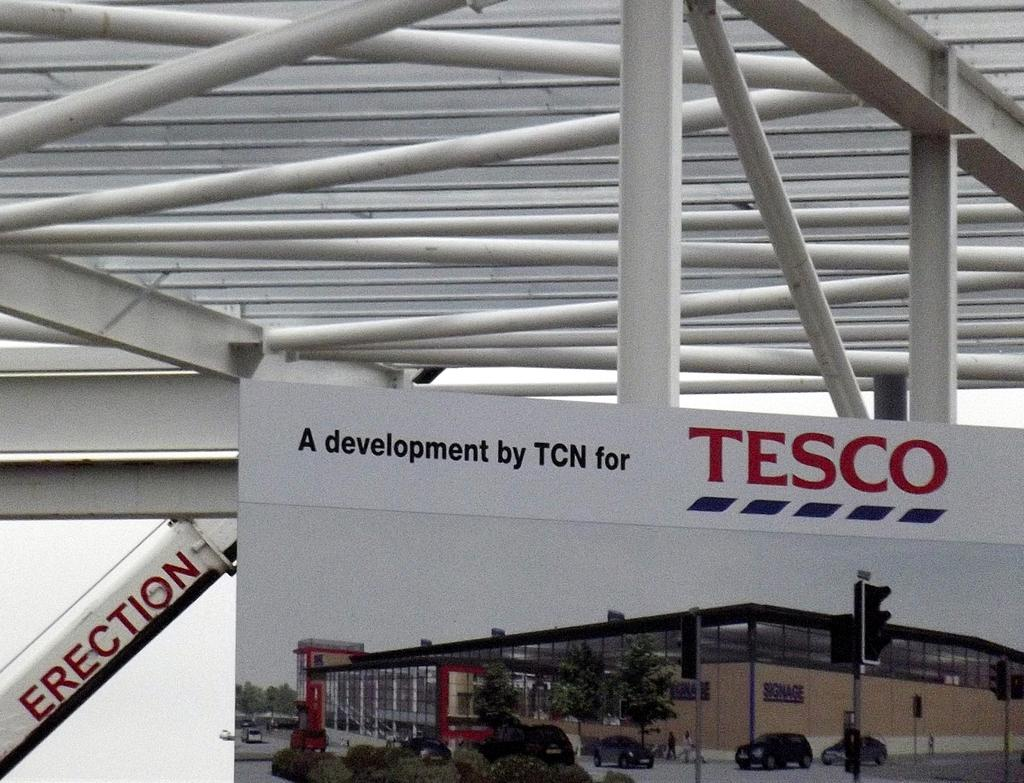What type of poster is in the image? There is a banner poster in the image. What can be seen supporting the poster? White iron frames are visible in the image, supporting the poster. What type of box is visible on the banner poster in the image? There is no box visible on the banner poster in the image. What type of school is associated with the banner poster in the image? There is no information about a school in the image, as it only features a banner poster and white iron frames. 